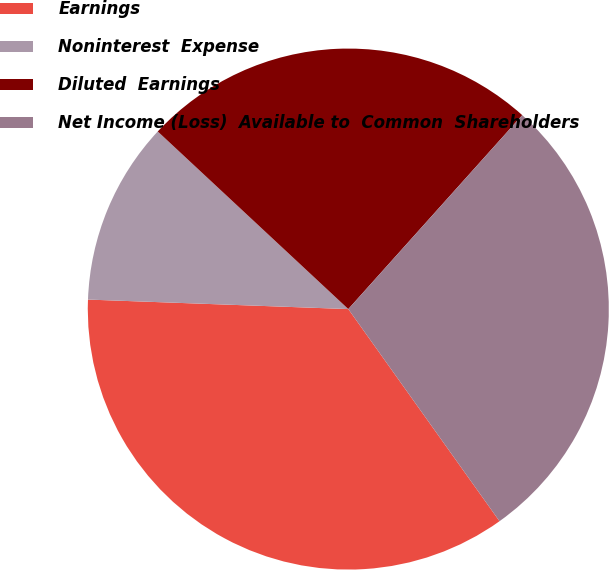Convert chart. <chart><loc_0><loc_0><loc_500><loc_500><pie_chart><fcel>Earnings<fcel>Noninterest  Expense<fcel>Diluted  Earnings<fcel>Net Income (Loss)  Available to  Common  Shareholders<nl><fcel>35.44%<fcel>11.36%<fcel>24.7%<fcel>28.51%<nl></chart> 